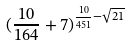Convert formula to latex. <formula><loc_0><loc_0><loc_500><loc_500>( \frac { 1 0 } { 1 6 4 } + 7 ) ^ { \frac { 1 0 } { 4 5 1 } - \sqrt { 2 1 } }</formula> 